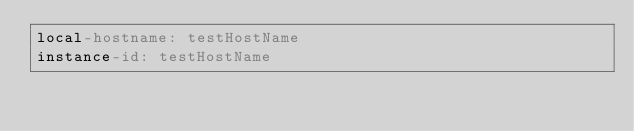Convert code to text. <code><loc_0><loc_0><loc_500><loc_500><_YAML_>local-hostname: testHostName
instance-id: testHostName
</code> 